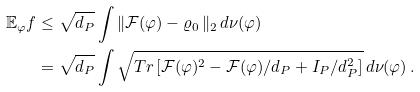Convert formula to latex. <formula><loc_0><loc_0><loc_500><loc_500>\mathbb { E } _ { \varphi } f & \leq \sqrt { d _ { P } } \int \| \mathcal { F } ( \varphi ) - \varrho _ { 0 } \, \| _ { 2 } \, d \nu ( \varphi ) \\ & = \sqrt { d _ { P } } \int \sqrt { T r \left [ \mathcal { F } ( \varphi ) ^ { 2 } - \mathcal { F } ( \varphi ) / d _ { P } + I _ { P } / d _ { P } ^ { 2 } \right ] } \, d \nu ( \varphi ) \, .</formula> 